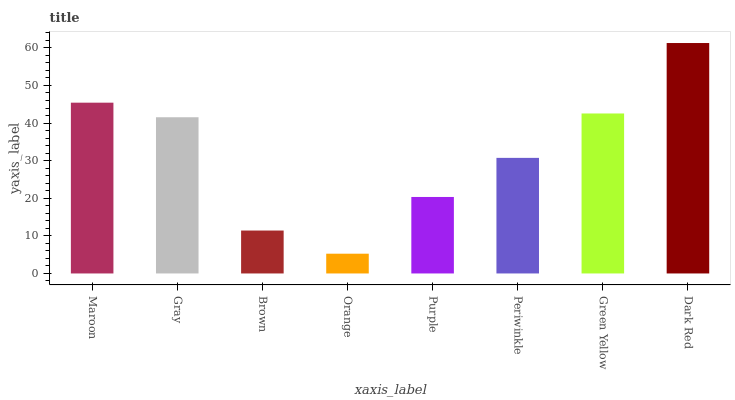Is Orange the minimum?
Answer yes or no. Yes. Is Dark Red the maximum?
Answer yes or no. Yes. Is Gray the minimum?
Answer yes or no. No. Is Gray the maximum?
Answer yes or no. No. Is Maroon greater than Gray?
Answer yes or no. Yes. Is Gray less than Maroon?
Answer yes or no. Yes. Is Gray greater than Maroon?
Answer yes or no. No. Is Maroon less than Gray?
Answer yes or no. No. Is Gray the high median?
Answer yes or no. Yes. Is Periwinkle the low median?
Answer yes or no. Yes. Is Green Yellow the high median?
Answer yes or no. No. Is Green Yellow the low median?
Answer yes or no. No. 